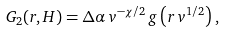Convert formula to latex. <formula><loc_0><loc_0><loc_500><loc_500>G _ { 2 } ( r , H ) = \Delta \alpha \, v ^ { - \chi / 2 } \, g \left ( r \, v ^ { 1 / 2 } \right ) ,</formula> 